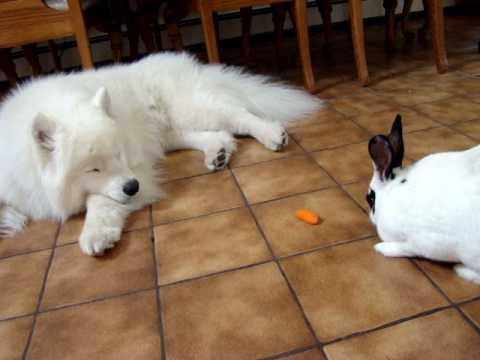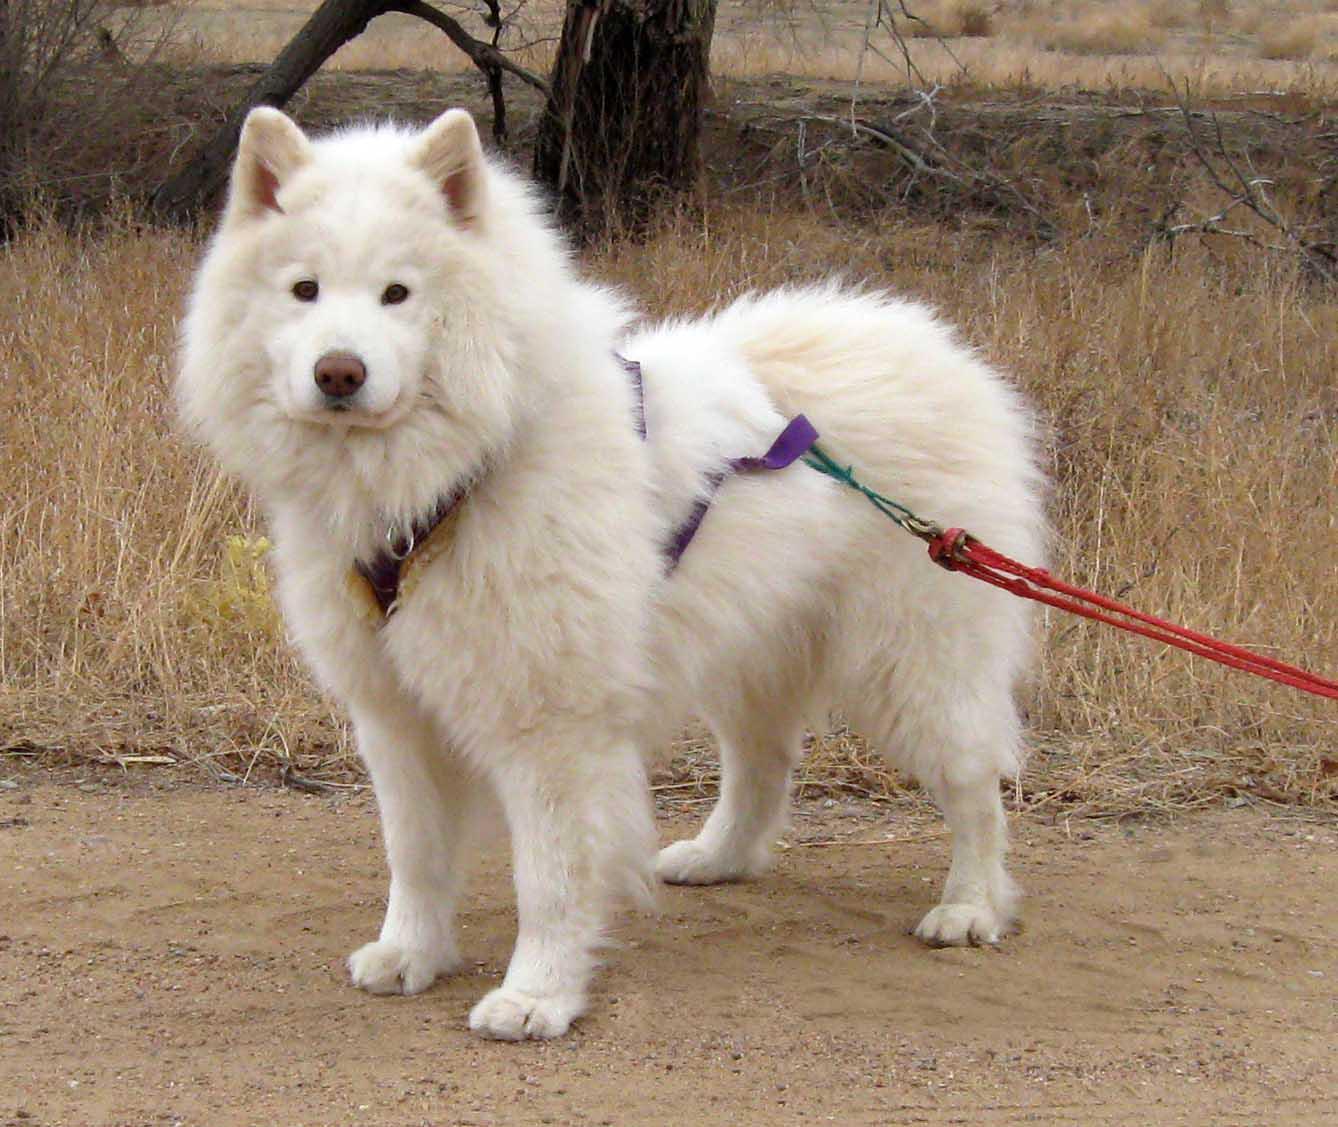The first image is the image on the left, the second image is the image on the right. For the images shown, is this caption "One image features a rabbit next to a dog." true? Answer yes or no. Yes. The first image is the image on the left, the second image is the image on the right. Analyze the images presented: Is the assertion "The left image contains a dog interacting with a rabbit." valid? Answer yes or no. Yes. 